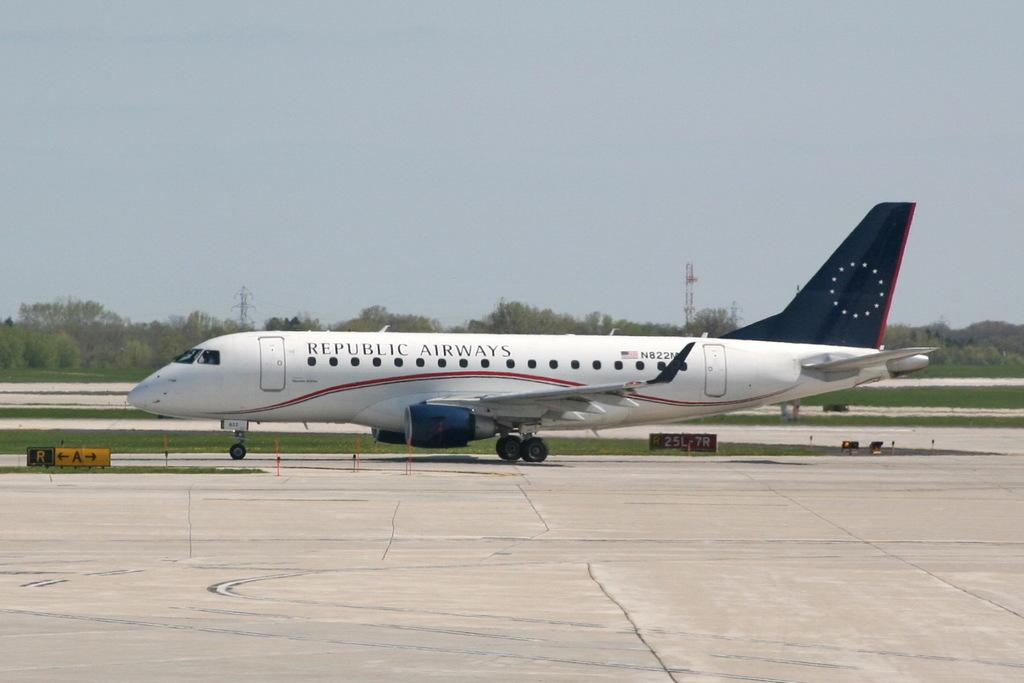<image>
Summarize the visual content of the image. A white and blue airplane on the running that says Republic Airways. 